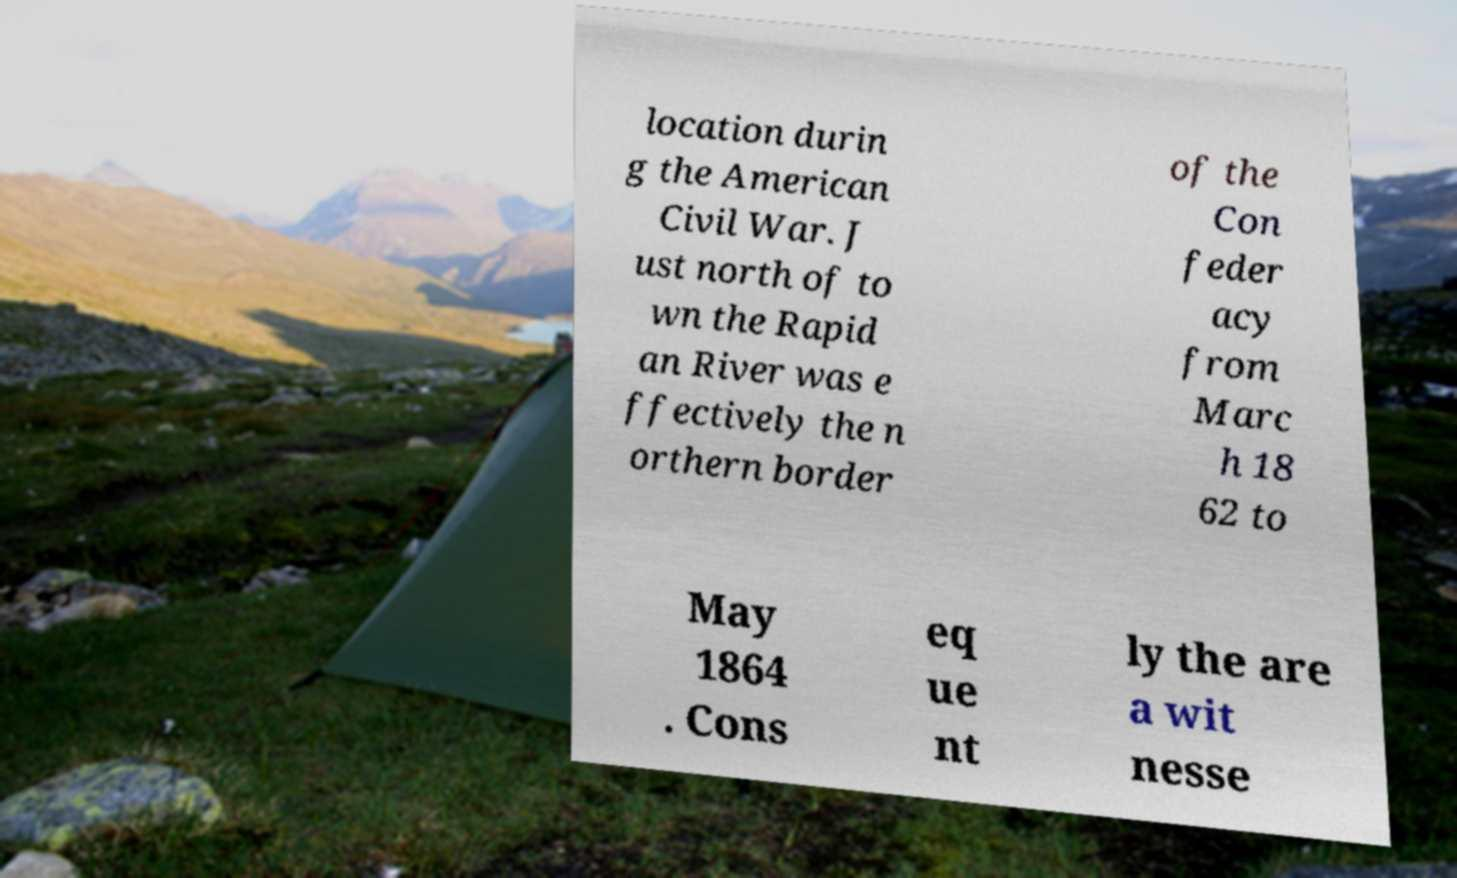There's text embedded in this image that I need extracted. Can you transcribe it verbatim? location durin g the American Civil War. J ust north of to wn the Rapid an River was e ffectively the n orthern border of the Con feder acy from Marc h 18 62 to May 1864 . Cons eq ue nt ly the are a wit nesse 